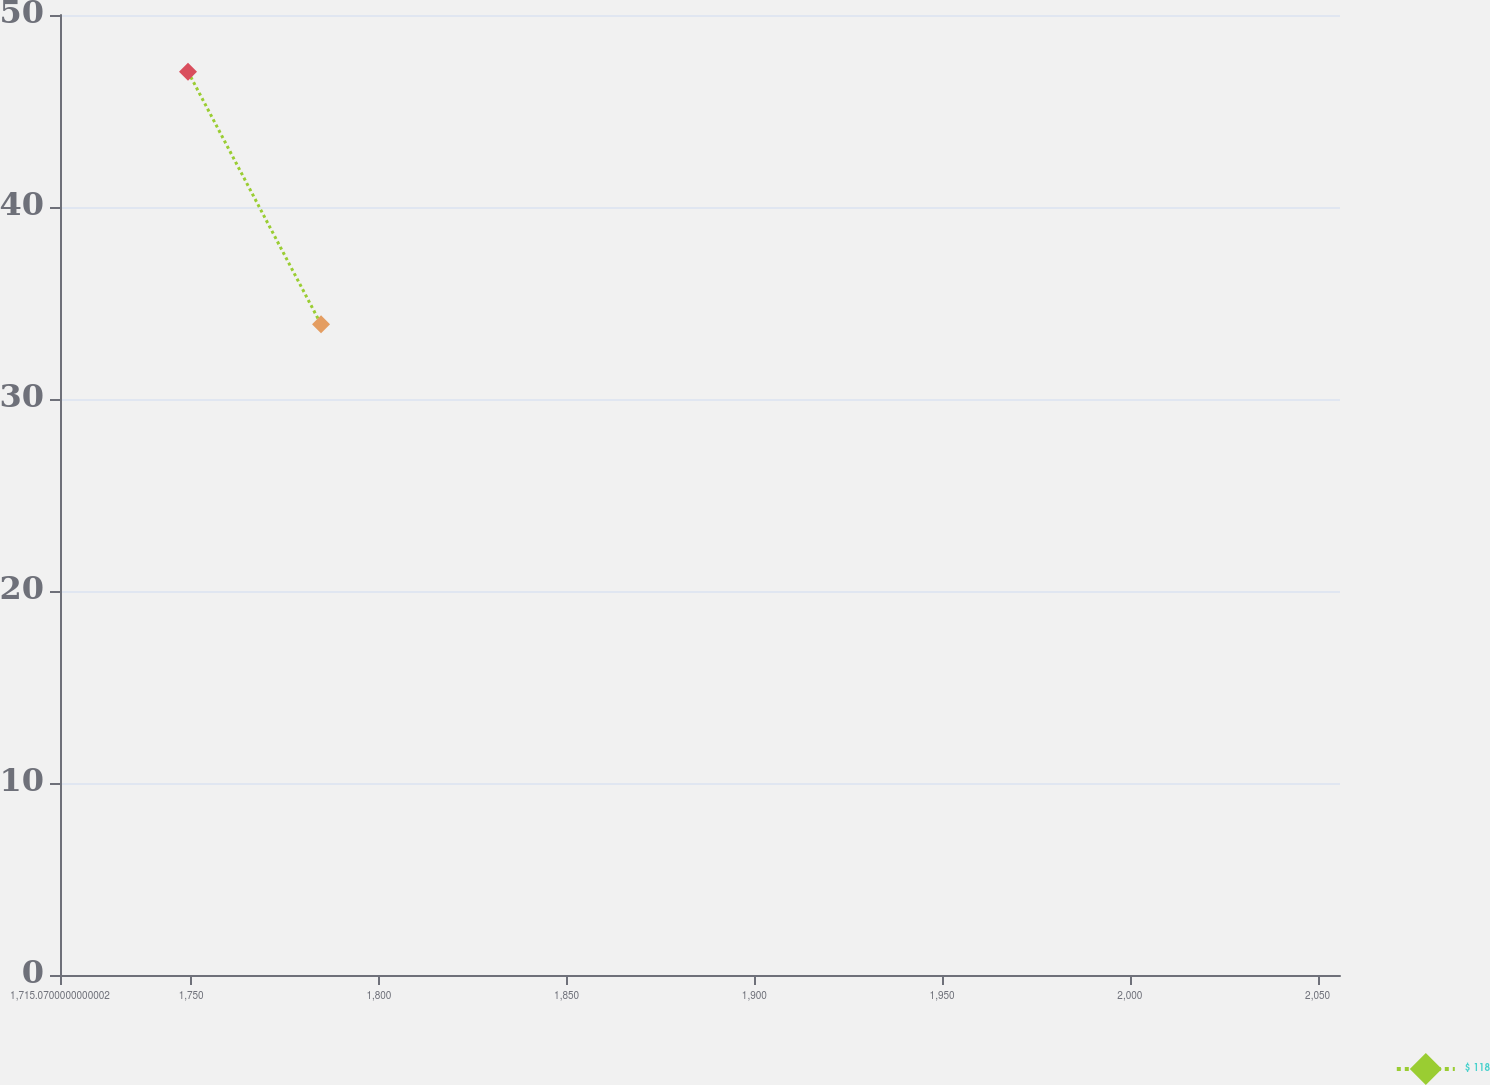<chart> <loc_0><loc_0><loc_500><loc_500><line_chart><ecel><fcel>$ 118<nl><fcel>1749.16<fcel>47.05<nl><fcel>1784.59<fcel>33.89<nl><fcel>2058.63<fcel>23.89<nl><fcel>2090.06<fcel>6.93<nl></chart> 